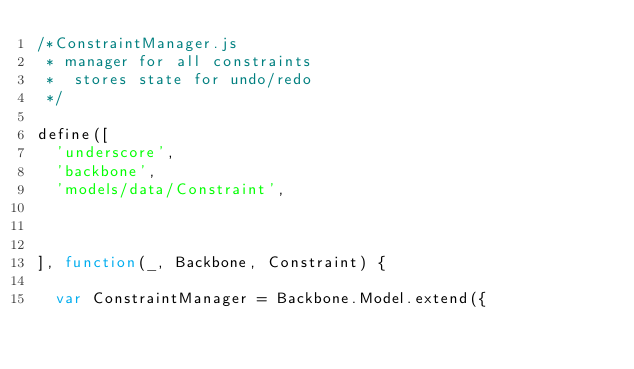Convert code to text. <code><loc_0><loc_0><loc_500><loc_500><_JavaScript_>/*ConstraintManager.js
 * manager for all constraints 
 *  stores state for undo/redo
 */

define([
	'underscore',
	'backbone',
	'models/data/Constraint',



], function(_, Backbone, Constraint) {

	var ConstraintManager = Backbone.Model.extend({
</code> 